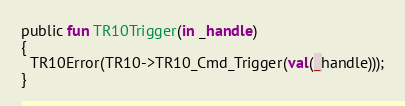<code> <loc_0><loc_0><loc_500><loc_500><_SML_>public fun TR10Trigger(in _handle)
{
  TR10Error(TR10->TR10_Cmd_Trigger(val(_handle)));
}
</code> 